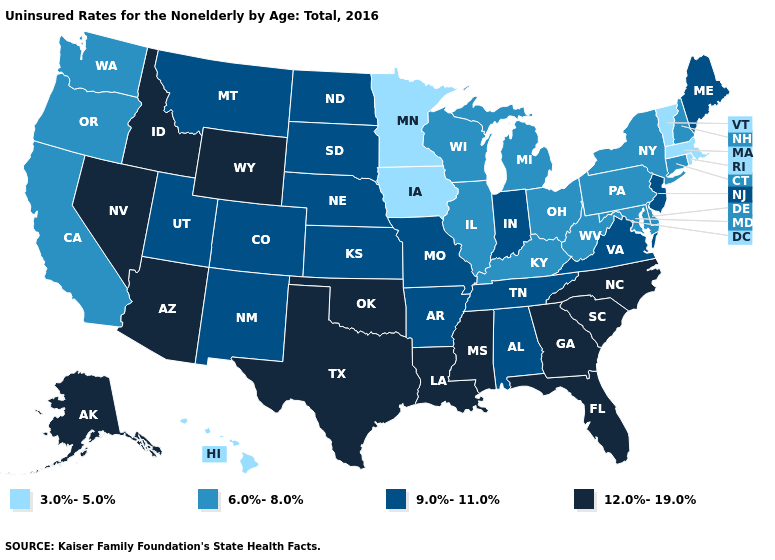What is the value of Florida?
Keep it brief. 12.0%-19.0%. Name the states that have a value in the range 9.0%-11.0%?
Give a very brief answer. Alabama, Arkansas, Colorado, Indiana, Kansas, Maine, Missouri, Montana, Nebraska, New Jersey, New Mexico, North Dakota, South Dakota, Tennessee, Utah, Virginia. What is the highest value in the USA?
Give a very brief answer. 12.0%-19.0%. Name the states that have a value in the range 9.0%-11.0%?
Short answer required. Alabama, Arkansas, Colorado, Indiana, Kansas, Maine, Missouri, Montana, Nebraska, New Jersey, New Mexico, North Dakota, South Dakota, Tennessee, Utah, Virginia. Name the states that have a value in the range 6.0%-8.0%?
Quick response, please. California, Connecticut, Delaware, Illinois, Kentucky, Maryland, Michigan, New Hampshire, New York, Ohio, Oregon, Pennsylvania, Washington, West Virginia, Wisconsin. Name the states that have a value in the range 12.0%-19.0%?
Be succinct. Alaska, Arizona, Florida, Georgia, Idaho, Louisiana, Mississippi, Nevada, North Carolina, Oklahoma, South Carolina, Texas, Wyoming. Name the states that have a value in the range 3.0%-5.0%?
Write a very short answer. Hawaii, Iowa, Massachusetts, Minnesota, Rhode Island, Vermont. What is the value of West Virginia?
Concise answer only. 6.0%-8.0%. Does the first symbol in the legend represent the smallest category?
Quick response, please. Yes. What is the highest value in states that border Nevada?
Answer briefly. 12.0%-19.0%. What is the value of New Jersey?
Keep it brief. 9.0%-11.0%. Does New Jersey have a higher value than Delaware?
Short answer required. Yes. Does New Hampshire have the same value as Virginia?
Give a very brief answer. No. What is the lowest value in the West?
Short answer required. 3.0%-5.0%. Name the states that have a value in the range 3.0%-5.0%?
Write a very short answer. Hawaii, Iowa, Massachusetts, Minnesota, Rhode Island, Vermont. 